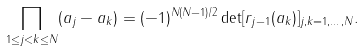<formula> <loc_0><loc_0><loc_500><loc_500>\prod _ { 1 \leq j < k \leq N } ( a _ { j } - a _ { k } ) = ( - 1 ) ^ { N ( N - 1 ) / 2 } \det [ r _ { j - 1 } ( a _ { k } ) ] _ { j , k = 1 , \dots , N } .</formula> 